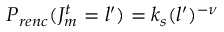<formula> <loc_0><loc_0><loc_500><loc_500>P _ { r e n c } ( J _ { m } ^ { t } = l ^ { \prime } ) = k _ { s } ( l ^ { \prime } ) ^ { - \nu }</formula> 